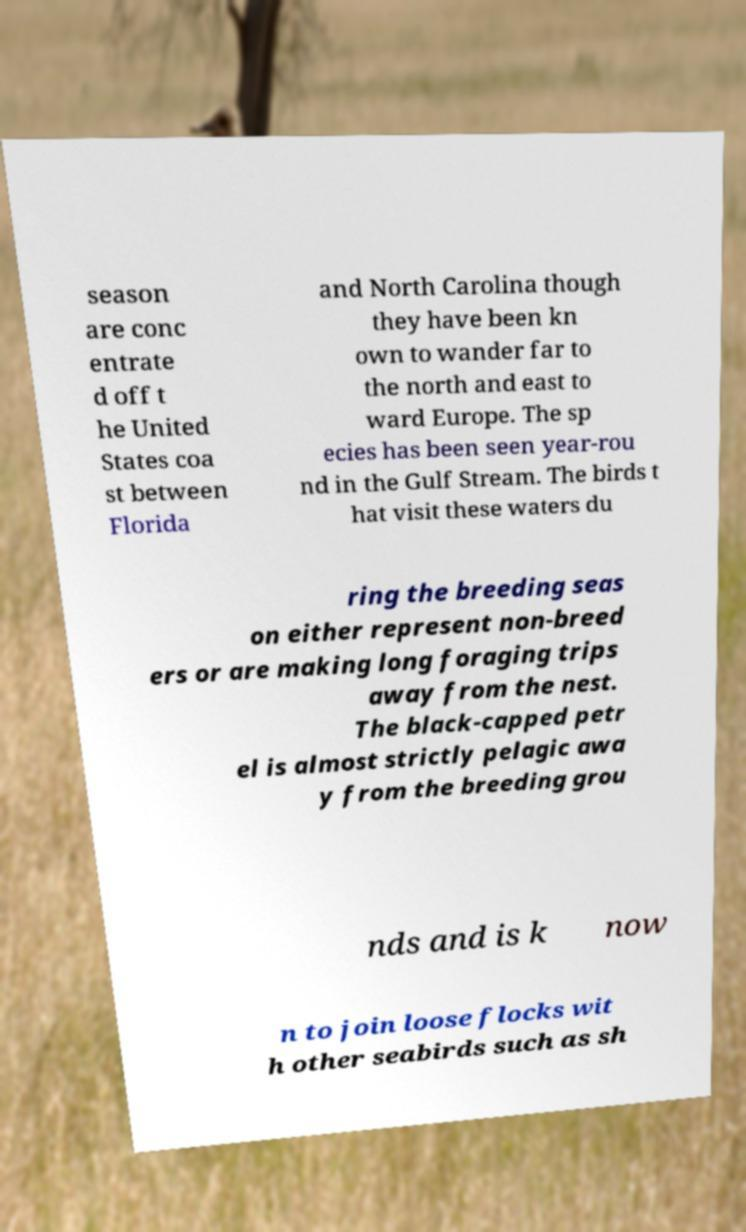I need the written content from this picture converted into text. Can you do that? season are conc entrate d off t he United States coa st between Florida and North Carolina though they have been kn own to wander far to the north and east to ward Europe. The sp ecies has been seen year-rou nd in the Gulf Stream. The birds t hat visit these waters du ring the breeding seas on either represent non-breed ers or are making long foraging trips away from the nest. The black-capped petr el is almost strictly pelagic awa y from the breeding grou nds and is k now n to join loose flocks wit h other seabirds such as sh 